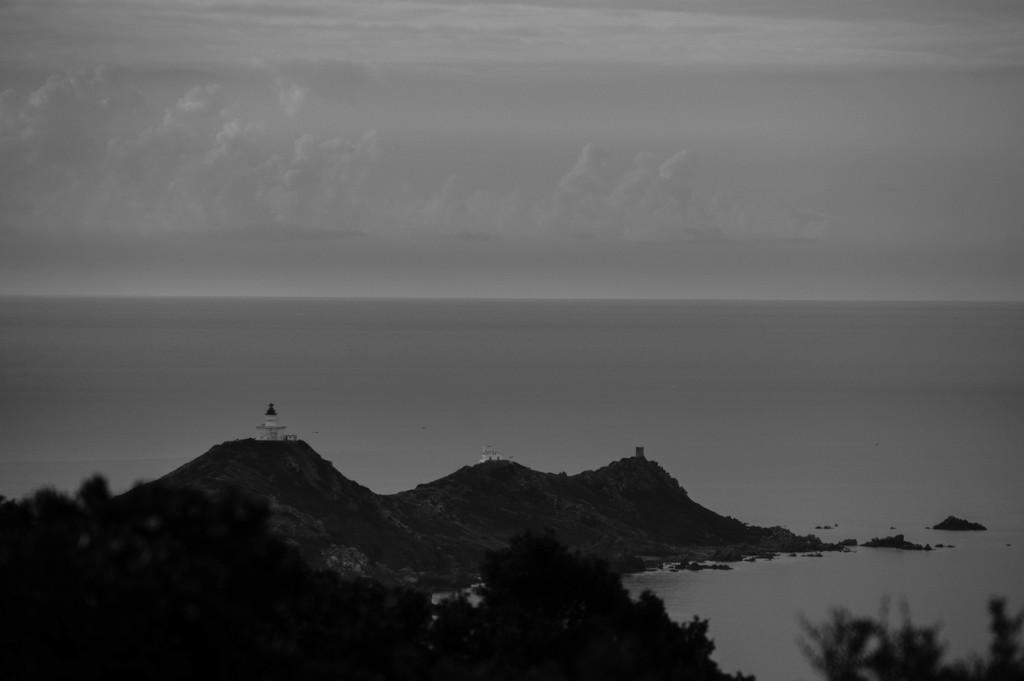What is the primary element in the image? There is water in the image. What type of natural landforms can be seen in the image? There are mountains in the image. What type of vegetation is present in the image? There are trees in the image. What is visible in the background of the image? The sky is visible in the background of the image. What can be observed in the sky? Clouds are present in the sky. What type of music can be heard playing in the background of the image? There is no music present in the image, as it is a visual representation and does not include sound. 